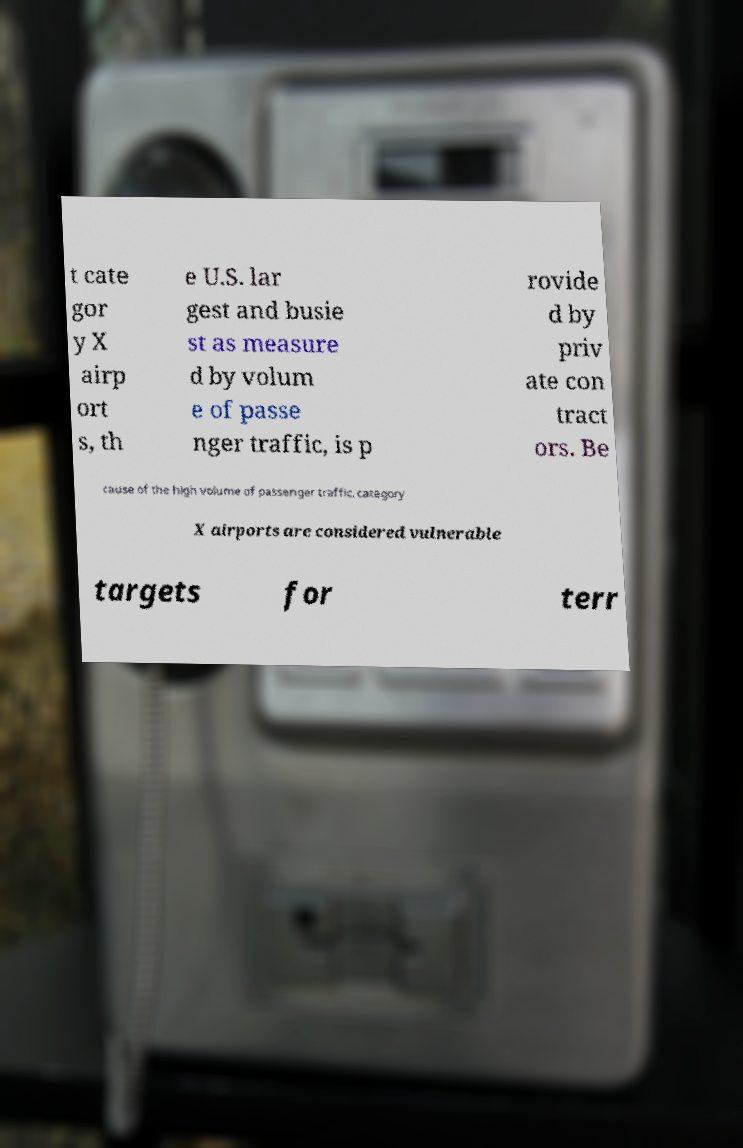Can you accurately transcribe the text from the provided image for me? t cate gor y X airp ort s, th e U.S. lar gest and busie st as measure d by volum e of passe nger traffic, is p rovide d by priv ate con tract ors. Be cause of the high volume of passenger traffic, category X airports are considered vulnerable targets for terr 